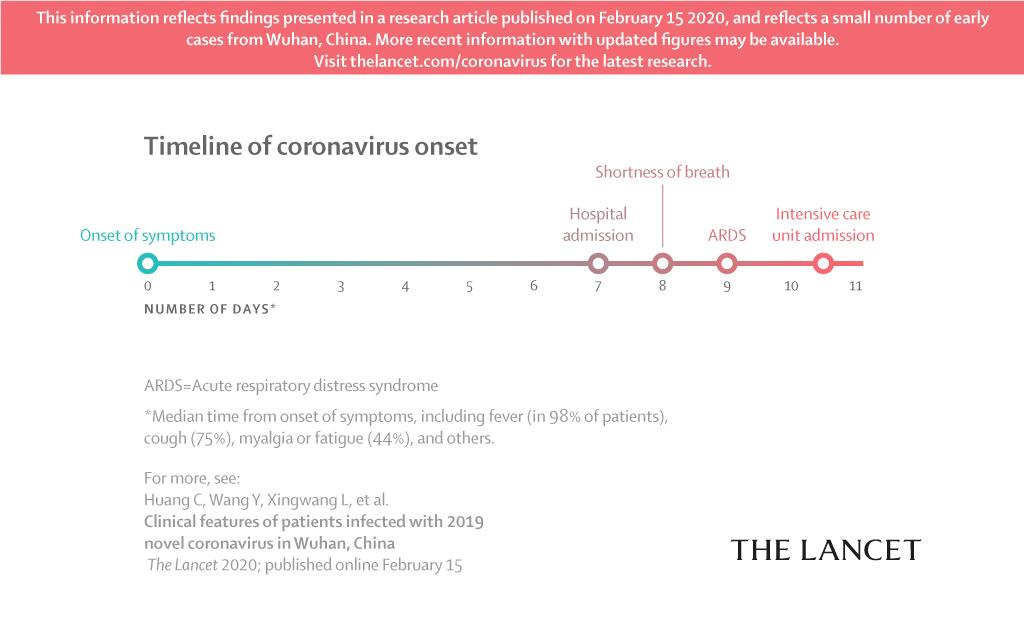Specify some key components in this picture. On the ninth day of being diagnosed with COVID-19, the patient exhibited symptoms consistent with acute respiratory distress syndrome (ARDS). The percentage of COVID-19 patients who are not experiencing fatigue as a symptom is 56%. Approximately 25% of patients with COVID-19 do not present with a cough as their main symptom, according to recent studies. Upon admission to the hospital, the first symptom observed in the patient was shortness of breath. It is estimated that approximately 2% of patients with COVID-19, also known as the coronavirus, are not experiencing fever as a symptom of the illness. 